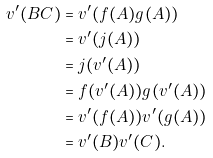Convert formula to latex. <formula><loc_0><loc_0><loc_500><loc_500>v ^ { \prime } ( B C ) & = v ^ { \prime } ( f ( A ) g ( A ) ) \\ & = v ^ { \prime } ( j ( A ) ) \\ & = j ( v ^ { \prime } ( A ) ) \\ & = f ( v ^ { \prime } ( A ) ) g ( v ^ { \prime } ( A ) ) \\ & = v ^ { \prime } ( f ( A ) ) v ^ { \prime } ( g ( A ) ) \\ & = v ^ { \prime } ( B ) v ^ { \prime } ( C ) .</formula> 